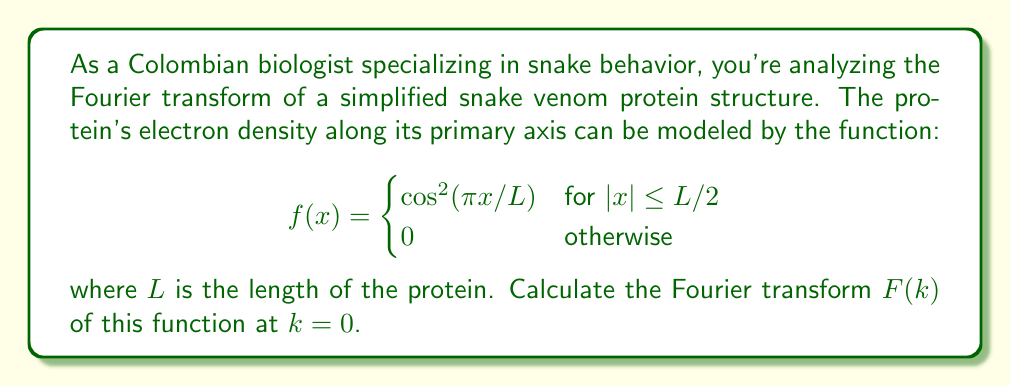Provide a solution to this math problem. To solve this problem, we need to follow these steps:

1) The Fourier transform is defined as:
   $$F(k) = \int_{-\infty}^{\infty} f(x) e^{-ikx} dx$$

2) Given the function is non-zero only in the interval $[-L/2, L/2]$, we can write:
   $$F(k) = \int_{-L/2}^{L/2} \cos^2(\pi x/L) e^{-ikx} dx$$

3) At $k = 0$, this simplifies to:
   $$F(0) = \int_{-L/2}^{L/2} \cos^2(\pi x/L) dx$$

4) We can use the trigonometric identity: $\cos^2(x) = \frac{1}{2}(1 + \cos(2x))$
   $$F(0) = \int_{-L/2}^{L/2} \frac{1}{2}(1 + \cos(2\pi x/L)) dx$$

5) This can be split into two integrals:
   $$F(0) = \frac{1}{2}\int_{-L/2}^{L/2} dx + \frac{1}{2}\int_{-L/2}^{L/2} \cos(2\pi x/L) dx$$

6) The first integral is straightforward:
   $$\frac{1}{2}\int_{-L/2}^{L/2} dx = \frac{1}{2}L$$

7) For the second integral:
   $$\frac{1}{2}\int_{-L/2}^{L/2} \cos(2\pi x/L) dx = \frac{1}{2} \cdot \frac{L}{2\pi} [\sin(2\pi x/L)]_{-L/2}^{L/2} = 0$$

8) Therefore, the final result is:
   $$F(0) = \frac{1}{2}L$$
Answer: $F(0) = \frac{1}{2}L$ 